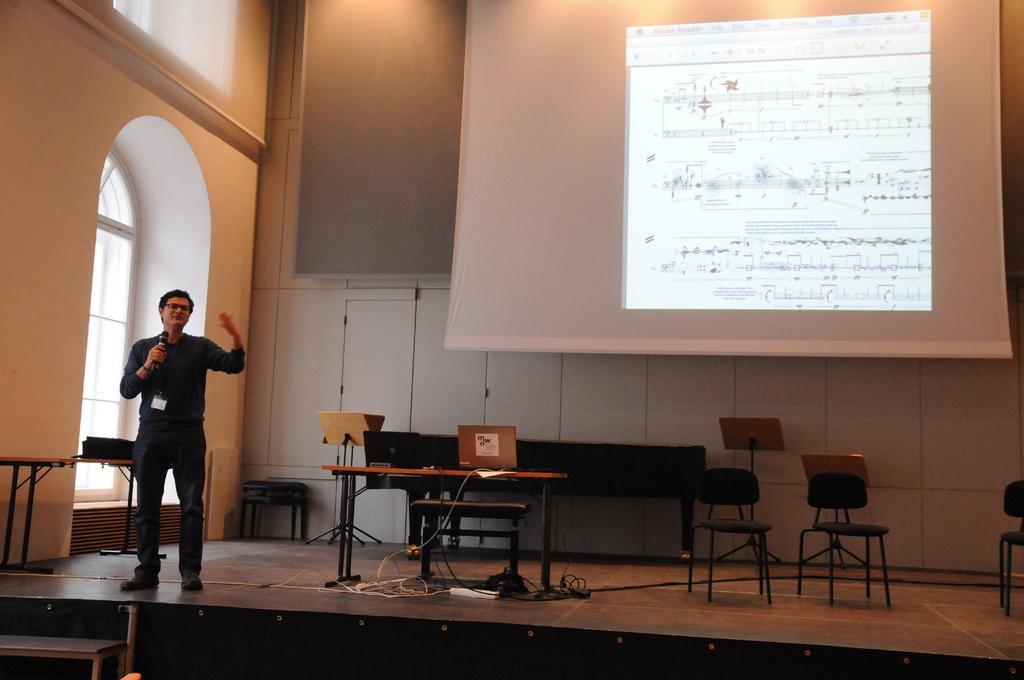Could you give a brief overview of what you see in this image? Person is standing holding microphone,this is door ,this is table and a chair and in the back there is screen, these are cables. 